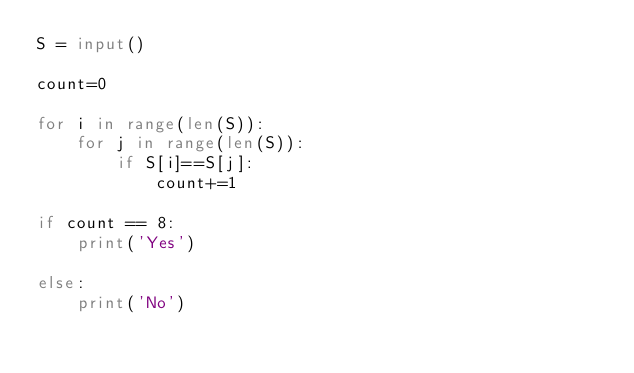<code> <loc_0><loc_0><loc_500><loc_500><_Python_>S = input()  

count=0

for i in range(len(S)):
    for j in range(len(S)):
        if S[i]==S[j]:
            count+=1

if count == 8:
    print('Yes')

else:
    print('No')</code> 